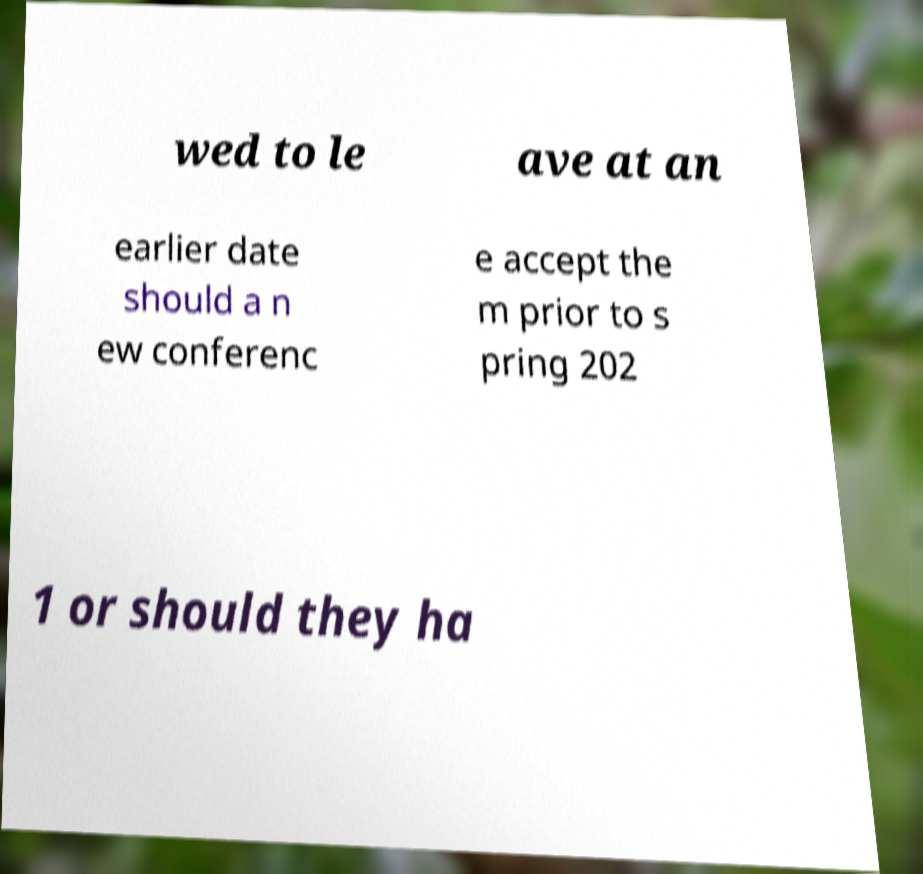I need the written content from this picture converted into text. Can you do that? wed to le ave at an earlier date should a n ew conferenc e accept the m prior to s pring 202 1 or should they ha 